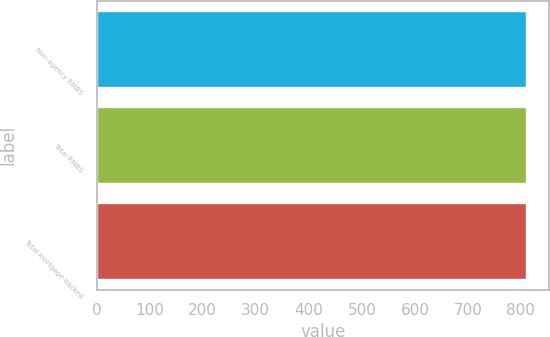<chart> <loc_0><loc_0><loc_500><loc_500><bar_chart><fcel>Non-agency RMBS<fcel>Total RMBS<fcel>Total mortgage-backed<nl><fcel>812<fcel>812.1<fcel>812.2<nl></chart> 